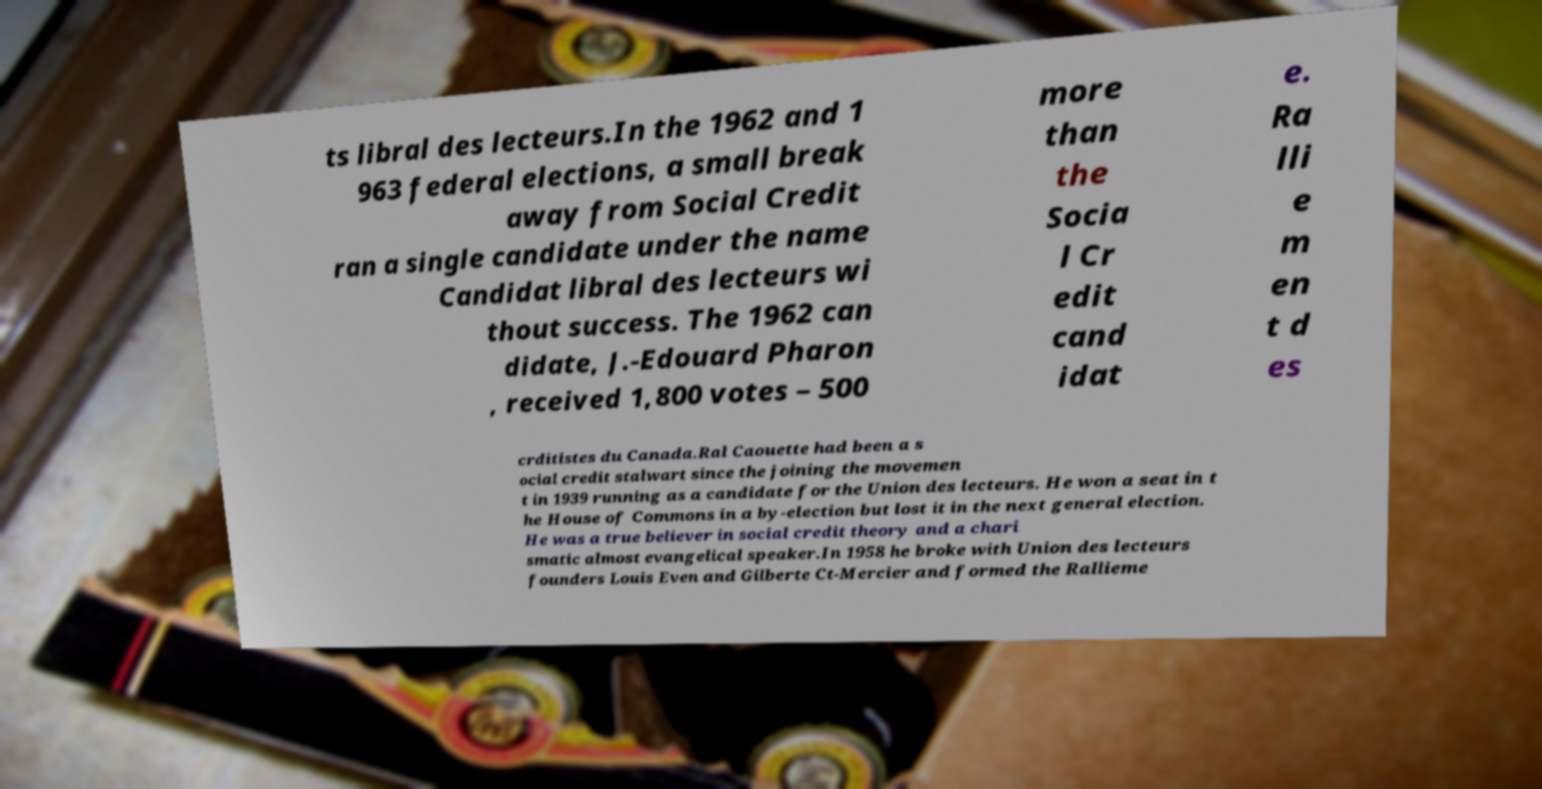Can you accurately transcribe the text from the provided image for me? ts libral des lecteurs.In the 1962 and 1 963 federal elections, a small break away from Social Credit ran a single candidate under the name Candidat libral des lecteurs wi thout success. The 1962 can didate, J.-Edouard Pharon , received 1,800 votes – 500 more than the Socia l Cr edit cand idat e. Ra lli e m en t d es crditistes du Canada.Ral Caouette had been a s ocial credit stalwart since the joining the movemen t in 1939 running as a candidate for the Union des lecteurs. He won a seat in t he House of Commons in a by-election but lost it in the next general election. He was a true believer in social credit theory and a chari smatic almost evangelical speaker.In 1958 he broke with Union des lecteurs founders Louis Even and Gilberte Ct-Mercier and formed the Rallieme 